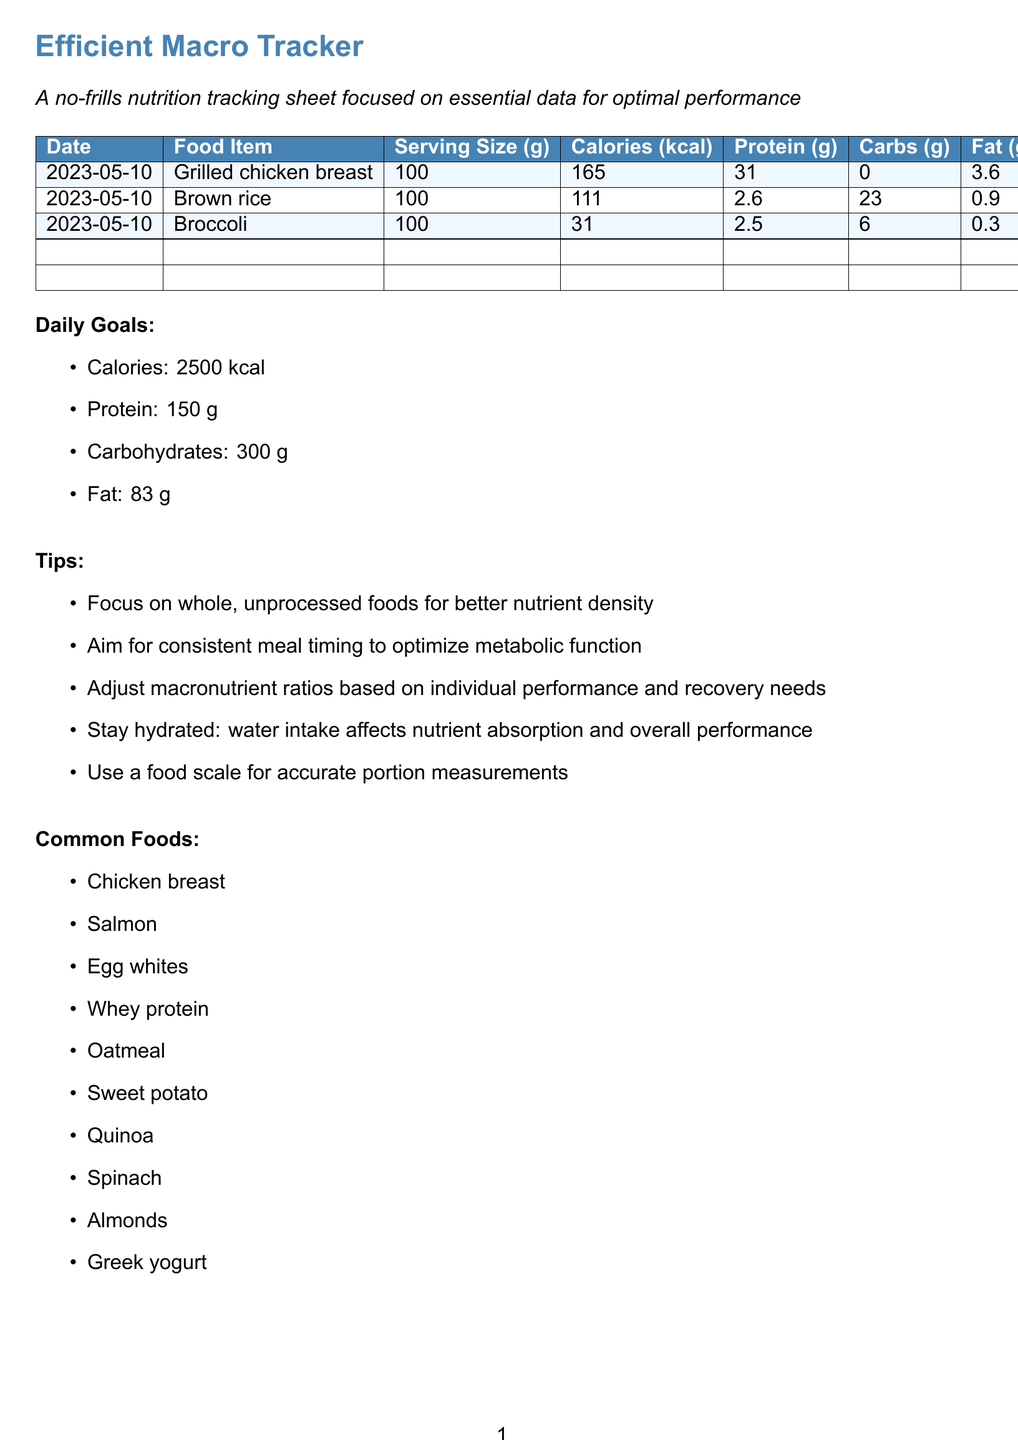What is the title of the document? The title of the document is clearly stated at the beginning and indicates its purpose.
Answer: Efficient Macro Tracker What is the serving size of grilled chicken breast? The serving size for grilled chicken breast is listed in grams in the table.
Answer: 100 How many grams of protein are in brown rice? The protein content for brown rice is found in the nutrition tracking table.
Answer: 2.6 What is the total daily calorie goal? The total daily calorie goal is specified in the daily goals section of the document.
Answer: 2500 What is the fat content in broccoli? The fat content in broccoli is provided in the nutrition tracking table.
Answer: 0.3 Which food item contains the highest protein per serving? A comparison of protein content across the food items helps determine which one is highest.
Answer: Grilled chicken breast How many grams of carbohydrates are in 100 grams of sweet potato? Sweet potato’s carbohydrate content can be inferred based on common foods but is not directly available.
Answer: N/A What are the tips related to meal timing? The document lists tips to optimize meal timing, which is one of the aspects mentioned in the tips section.
Answer: Aim for consistent meal timing to optimize metabolic function What is listed as a common food? Common foods are specified in a dedicated section, indicating examples to include in a diet.
Answer: Chicken breast 